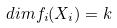Convert formula to latex. <formula><loc_0><loc_0><loc_500><loc_500>d i m f _ { i } ( X _ { i } ) = k</formula> 